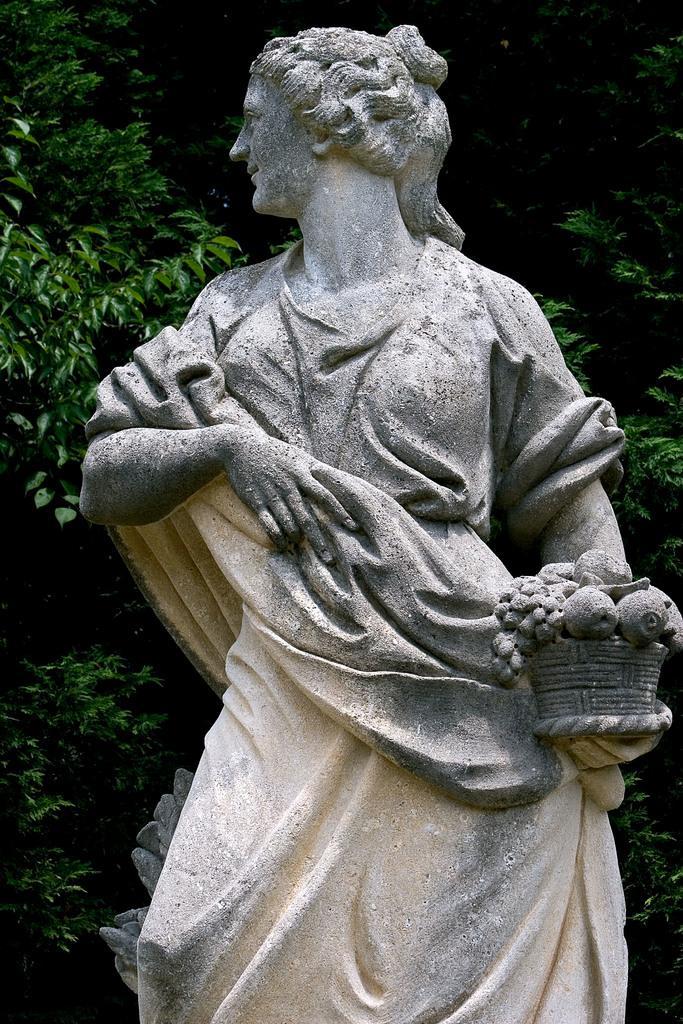Could you give a brief overview of what you see in this image? In this image there is a statue. In the background there are trees. In the middle there is a statue of a girl who is holding the basket. In the basket there are fruits. 